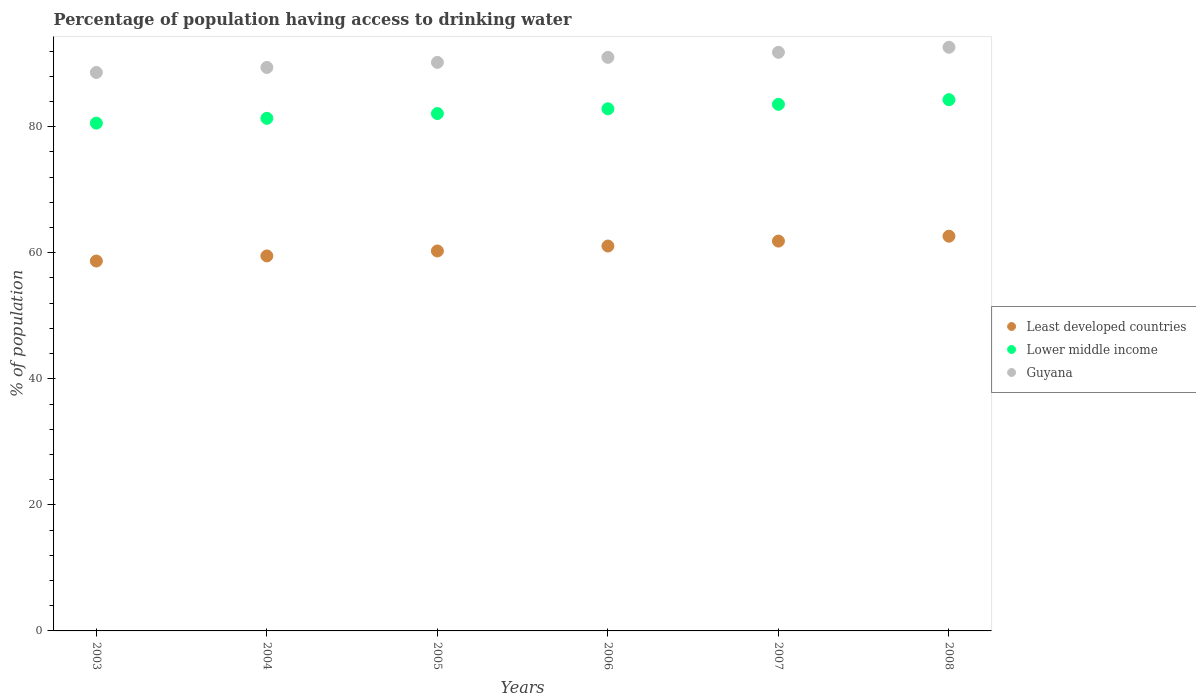What is the percentage of population having access to drinking water in Lower middle income in 2006?
Your response must be concise. 82.84. Across all years, what is the maximum percentage of population having access to drinking water in Guyana?
Provide a short and direct response. 92.6. Across all years, what is the minimum percentage of population having access to drinking water in Guyana?
Provide a succinct answer. 88.6. What is the total percentage of population having access to drinking water in Guyana in the graph?
Offer a very short reply. 543.6. What is the difference between the percentage of population having access to drinking water in Lower middle income in 2006 and that in 2008?
Make the answer very short. -1.45. What is the difference between the percentage of population having access to drinking water in Least developed countries in 2003 and the percentage of population having access to drinking water in Lower middle income in 2005?
Give a very brief answer. -23.4. What is the average percentage of population having access to drinking water in Lower middle income per year?
Your answer should be very brief. 82.44. In the year 2007, what is the difference between the percentage of population having access to drinking water in Least developed countries and percentage of population having access to drinking water in Guyana?
Your response must be concise. -29.95. In how many years, is the percentage of population having access to drinking water in Least developed countries greater than 20 %?
Your answer should be compact. 6. What is the ratio of the percentage of population having access to drinking water in Lower middle income in 2003 to that in 2008?
Make the answer very short. 0.96. Is the difference between the percentage of population having access to drinking water in Least developed countries in 2007 and 2008 greater than the difference between the percentage of population having access to drinking water in Guyana in 2007 and 2008?
Your response must be concise. Yes. What is the difference between the highest and the second highest percentage of population having access to drinking water in Guyana?
Make the answer very short. 0.8. What is the difference between the highest and the lowest percentage of population having access to drinking water in Lower middle income?
Offer a terse response. 3.72. Is it the case that in every year, the sum of the percentage of population having access to drinking water in Guyana and percentage of population having access to drinking water in Least developed countries  is greater than the percentage of population having access to drinking water in Lower middle income?
Give a very brief answer. Yes. Is the percentage of population having access to drinking water in Lower middle income strictly less than the percentage of population having access to drinking water in Guyana over the years?
Offer a very short reply. Yes. How many dotlines are there?
Give a very brief answer. 3. Where does the legend appear in the graph?
Offer a terse response. Center right. How many legend labels are there?
Make the answer very short. 3. How are the legend labels stacked?
Your answer should be very brief. Vertical. What is the title of the graph?
Ensure brevity in your answer.  Percentage of population having access to drinking water. What is the label or title of the Y-axis?
Keep it short and to the point. % of population. What is the % of population of Least developed countries in 2003?
Keep it short and to the point. 58.69. What is the % of population of Lower middle income in 2003?
Your answer should be compact. 80.56. What is the % of population of Guyana in 2003?
Offer a terse response. 88.6. What is the % of population of Least developed countries in 2004?
Give a very brief answer. 59.5. What is the % of population in Lower middle income in 2004?
Your answer should be very brief. 81.33. What is the % of population in Guyana in 2004?
Your answer should be compact. 89.4. What is the % of population in Least developed countries in 2005?
Make the answer very short. 60.28. What is the % of population in Lower middle income in 2005?
Offer a very short reply. 82.08. What is the % of population of Guyana in 2005?
Keep it short and to the point. 90.2. What is the % of population of Least developed countries in 2006?
Provide a succinct answer. 61.06. What is the % of population in Lower middle income in 2006?
Your response must be concise. 82.84. What is the % of population in Guyana in 2006?
Offer a terse response. 91. What is the % of population in Least developed countries in 2007?
Give a very brief answer. 61.85. What is the % of population of Lower middle income in 2007?
Your answer should be very brief. 83.55. What is the % of population in Guyana in 2007?
Offer a very short reply. 91.8. What is the % of population in Least developed countries in 2008?
Make the answer very short. 62.62. What is the % of population of Lower middle income in 2008?
Provide a short and direct response. 84.28. What is the % of population in Guyana in 2008?
Give a very brief answer. 92.6. Across all years, what is the maximum % of population of Least developed countries?
Provide a short and direct response. 62.62. Across all years, what is the maximum % of population in Lower middle income?
Provide a succinct answer. 84.28. Across all years, what is the maximum % of population in Guyana?
Offer a terse response. 92.6. Across all years, what is the minimum % of population in Least developed countries?
Your answer should be compact. 58.69. Across all years, what is the minimum % of population in Lower middle income?
Provide a short and direct response. 80.56. Across all years, what is the minimum % of population of Guyana?
Your answer should be very brief. 88.6. What is the total % of population of Least developed countries in the graph?
Offer a terse response. 364. What is the total % of population in Lower middle income in the graph?
Keep it short and to the point. 494.64. What is the total % of population in Guyana in the graph?
Make the answer very short. 543.6. What is the difference between the % of population of Least developed countries in 2003 and that in 2004?
Make the answer very short. -0.81. What is the difference between the % of population of Lower middle income in 2003 and that in 2004?
Provide a succinct answer. -0.76. What is the difference between the % of population of Guyana in 2003 and that in 2004?
Offer a terse response. -0.8. What is the difference between the % of population in Least developed countries in 2003 and that in 2005?
Keep it short and to the point. -1.59. What is the difference between the % of population in Lower middle income in 2003 and that in 2005?
Provide a succinct answer. -1.52. What is the difference between the % of population of Least developed countries in 2003 and that in 2006?
Keep it short and to the point. -2.38. What is the difference between the % of population in Lower middle income in 2003 and that in 2006?
Your answer should be very brief. -2.27. What is the difference between the % of population in Least developed countries in 2003 and that in 2007?
Offer a terse response. -3.16. What is the difference between the % of population in Lower middle income in 2003 and that in 2007?
Your answer should be very brief. -2.98. What is the difference between the % of population of Guyana in 2003 and that in 2007?
Your response must be concise. -3.2. What is the difference between the % of population of Least developed countries in 2003 and that in 2008?
Your answer should be compact. -3.94. What is the difference between the % of population of Lower middle income in 2003 and that in 2008?
Ensure brevity in your answer.  -3.72. What is the difference between the % of population of Least developed countries in 2004 and that in 2005?
Make the answer very short. -0.79. What is the difference between the % of population of Lower middle income in 2004 and that in 2005?
Give a very brief answer. -0.76. What is the difference between the % of population of Least developed countries in 2004 and that in 2006?
Ensure brevity in your answer.  -1.57. What is the difference between the % of population in Lower middle income in 2004 and that in 2006?
Offer a very short reply. -1.51. What is the difference between the % of population of Guyana in 2004 and that in 2006?
Make the answer very short. -1.6. What is the difference between the % of population of Least developed countries in 2004 and that in 2007?
Keep it short and to the point. -2.35. What is the difference between the % of population of Lower middle income in 2004 and that in 2007?
Your answer should be compact. -2.22. What is the difference between the % of population of Guyana in 2004 and that in 2007?
Offer a very short reply. -2.4. What is the difference between the % of population in Least developed countries in 2004 and that in 2008?
Keep it short and to the point. -3.13. What is the difference between the % of population in Lower middle income in 2004 and that in 2008?
Your answer should be compact. -2.96. What is the difference between the % of population in Guyana in 2004 and that in 2008?
Your answer should be very brief. -3.2. What is the difference between the % of population in Least developed countries in 2005 and that in 2006?
Offer a very short reply. -0.78. What is the difference between the % of population of Lower middle income in 2005 and that in 2006?
Provide a short and direct response. -0.75. What is the difference between the % of population of Least developed countries in 2005 and that in 2007?
Offer a very short reply. -1.57. What is the difference between the % of population in Lower middle income in 2005 and that in 2007?
Offer a very short reply. -1.46. What is the difference between the % of population in Least developed countries in 2005 and that in 2008?
Ensure brevity in your answer.  -2.34. What is the difference between the % of population of Lower middle income in 2005 and that in 2008?
Make the answer very short. -2.2. What is the difference between the % of population in Least developed countries in 2006 and that in 2007?
Make the answer very short. -0.78. What is the difference between the % of population of Lower middle income in 2006 and that in 2007?
Your response must be concise. -0.71. What is the difference between the % of population of Least developed countries in 2006 and that in 2008?
Keep it short and to the point. -1.56. What is the difference between the % of population of Lower middle income in 2006 and that in 2008?
Offer a very short reply. -1.45. What is the difference between the % of population in Guyana in 2006 and that in 2008?
Ensure brevity in your answer.  -1.6. What is the difference between the % of population in Least developed countries in 2007 and that in 2008?
Your answer should be compact. -0.77. What is the difference between the % of population in Lower middle income in 2007 and that in 2008?
Offer a terse response. -0.74. What is the difference between the % of population of Least developed countries in 2003 and the % of population of Lower middle income in 2004?
Your answer should be compact. -22.64. What is the difference between the % of population of Least developed countries in 2003 and the % of population of Guyana in 2004?
Give a very brief answer. -30.71. What is the difference between the % of population of Lower middle income in 2003 and the % of population of Guyana in 2004?
Ensure brevity in your answer.  -8.84. What is the difference between the % of population in Least developed countries in 2003 and the % of population in Lower middle income in 2005?
Your answer should be compact. -23.4. What is the difference between the % of population in Least developed countries in 2003 and the % of population in Guyana in 2005?
Offer a very short reply. -31.51. What is the difference between the % of population of Lower middle income in 2003 and the % of population of Guyana in 2005?
Your answer should be very brief. -9.64. What is the difference between the % of population of Least developed countries in 2003 and the % of population of Lower middle income in 2006?
Keep it short and to the point. -24.15. What is the difference between the % of population of Least developed countries in 2003 and the % of population of Guyana in 2006?
Your response must be concise. -32.31. What is the difference between the % of population in Lower middle income in 2003 and the % of population in Guyana in 2006?
Make the answer very short. -10.44. What is the difference between the % of population in Least developed countries in 2003 and the % of population in Lower middle income in 2007?
Ensure brevity in your answer.  -24.86. What is the difference between the % of population in Least developed countries in 2003 and the % of population in Guyana in 2007?
Ensure brevity in your answer.  -33.11. What is the difference between the % of population of Lower middle income in 2003 and the % of population of Guyana in 2007?
Provide a succinct answer. -11.24. What is the difference between the % of population in Least developed countries in 2003 and the % of population in Lower middle income in 2008?
Offer a terse response. -25.6. What is the difference between the % of population in Least developed countries in 2003 and the % of population in Guyana in 2008?
Provide a succinct answer. -33.91. What is the difference between the % of population of Lower middle income in 2003 and the % of population of Guyana in 2008?
Give a very brief answer. -12.04. What is the difference between the % of population of Least developed countries in 2004 and the % of population of Lower middle income in 2005?
Give a very brief answer. -22.59. What is the difference between the % of population of Least developed countries in 2004 and the % of population of Guyana in 2005?
Your answer should be very brief. -30.7. What is the difference between the % of population of Lower middle income in 2004 and the % of population of Guyana in 2005?
Provide a short and direct response. -8.87. What is the difference between the % of population in Least developed countries in 2004 and the % of population in Lower middle income in 2006?
Your response must be concise. -23.34. What is the difference between the % of population in Least developed countries in 2004 and the % of population in Guyana in 2006?
Offer a very short reply. -31.5. What is the difference between the % of population of Lower middle income in 2004 and the % of population of Guyana in 2006?
Your answer should be very brief. -9.67. What is the difference between the % of population in Least developed countries in 2004 and the % of population in Lower middle income in 2007?
Offer a very short reply. -24.05. What is the difference between the % of population of Least developed countries in 2004 and the % of population of Guyana in 2007?
Offer a terse response. -32.3. What is the difference between the % of population of Lower middle income in 2004 and the % of population of Guyana in 2007?
Keep it short and to the point. -10.47. What is the difference between the % of population of Least developed countries in 2004 and the % of population of Lower middle income in 2008?
Make the answer very short. -24.79. What is the difference between the % of population in Least developed countries in 2004 and the % of population in Guyana in 2008?
Your response must be concise. -33.1. What is the difference between the % of population in Lower middle income in 2004 and the % of population in Guyana in 2008?
Your answer should be very brief. -11.27. What is the difference between the % of population in Least developed countries in 2005 and the % of population in Lower middle income in 2006?
Your answer should be compact. -22.56. What is the difference between the % of population in Least developed countries in 2005 and the % of population in Guyana in 2006?
Provide a short and direct response. -30.72. What is the difference between the % of population of Lower middle income in 2005 and the % of population of Guyana in 2006?
Keep it short and to the point. -8.92. What is the difference between the % of population in Least developed countries in 2005 and the % of population in Lower middle income in 2007?
Provide a succinct answer. -23.27. What is the difference between the % of population in Least developed countries in 2005 and the % of population in Guyana in 2007?
Your response must be concise. -31.52. What is the difference between the % of population of Lower middle income in 2005 and the % of population of Guyana in 2007?
Your answer should be compact. -9.72. What is the difference between the % of population in Least developed countries in 2005 and the % of population in Lower middle income in 2008?
Make the answer very short. -24. What is the difference between the % of population of Least developed countries in 2005 and the % of population of Guyana in 2008?
Provide a succinct answer. -32.32. What is the difference between the % of population of Lower middle income in 2005 and the % of population of Guyana in 2008?
Your answer should be compact. -10.52. What is the difference between the % of population in Least developed countries in 2006 and the % of population in Lower middle income in 2007?
Provide a succinct answer. -22.48. What is the difference between the % of population in Least developed countries in 2006 and the % of population in Guyana in 2007?
Your response must be concise. -30.74. What is the difference between the % of population of Lower middle income in 2006 and the % of population of Guyana in 2007?
Your answer should be very brief. -8.96. What is the difference between the % of population of Least developed countries in 2006 and the % of population of Lower middle income in 2008?
Give a very brief answer. -23.22. What is the difference between the % of population in Least developed countries in 2006 and the % of population in Guyana in 2008?
Provide a short and direct response. -31.54. What is the difference between the % of population in Lower middle income in 2006 and the % of population in Guyana in 2008?
Ensure brevity in your answer.  -9.76. What is the difference between the % of population of Least developed countries in 2007 and the % of population of Lower middle income in 2008?
Ensure brevity in your answer.  -22.44. What is the difference between the % of population of Least developed countries in 2007 and the % of population of Guyana in 2008?
Offer a very short reply. -30.75. What is the difference between the % of population in Lower middle income in 2007 and the % of population in Guyana in 2008?
Your response must be concise. -9.05. What is the average % of population in Least developed countries per year?
Your answer should be very brief. 60.67. What is the average % of population of Lower middle income per year?
Give a very brief answer. 82.44. What is the average % of population of Guyana per year?
Provide a succinct answer. 90.6. In the year 2003, what is the difference between the % of population in Least developed countries and % of population in Lower middle income?
Give a very brief answer. -21.88. In the year 2003, what is the difference between the % of population in Least developed countries and % of population in Guyana?
Provide a succinct answer. -29.91. In the year 2003, what is the difference between the % of population in Lower middle income and % of population in Guyana?
Your response must be concise. -8.04. In the year 2004, what is the difference between the % of population in Least developed countries and % of population in Lower middle income?
Your response must be concise. -21.83. In the year 2004, what is the difference between the % of population in Least developed countries and % of population in Guyana?
Make the answer very short. -29.9. In the year 2004, what is the difference between the % of population of Lower middle income and % of population of Guyana?
Keep it short and to the point. -8.07. In the year 2005, what is the difference between the % of population of Least developed countries and % of population of Lower middle income?
Keep it short and to the point. -21.8. In the year 2005, what is the difference between the % of population in Least developed countries and % of population in Guyana?
Your response must be concise. -29.92. In the year 2005, what is the difference between the % of population of Lower middle income and % of population of Guyana?
Your response must be concise. -8.12. In the year 2006, what is the difference between the % of population in Least developed countries and % of population in Lower middle income?
Ensure brevity in your answer.  -21.77. In the year 2006, what is the difference between the % of population of Least developed countries and % of population of Guyana?
Give a very brief answer. -29.94. In the year 2006, what is the difference between the % of population in Lower middle income and % of population in Guyana?
Give a very brief answer. -8.16. In the year 2007, what is the difference between the % of population of Least developed countries and % of population of Lower middle income?
Provide a succinct answer. -21.7. In the year 2007, what is the difference between the % of population of Least developed countries and % of population of Guyana?
Your answer should be compact. -29.95. In the year 2007, what is the difference between the % of population of Lower middle income and % of population of Guyana?
Give a very brief answer. -8.25. In the year 2008, what is the difference between the % of population in Least developed countries and % of population in Lower middle income?
Your answer should be very brief. -21.66. In the year 2008, what is the difference between the % of population of Least developed countries and % of population of Guyana?
Provide a succinct answer. -29.98. In the year 2008, what is the difference between the % of population in Lower middle income and % of population in Guyana?
Offer a very short reply. -8.32. What is the ratio of the % of population of Least developed countries in 2003 to that in 2004?
Offer a terse response. 0.99. What is the ratio of the % of population of Lower middle income in 2003 to that in 2004?
Give a very brief answer. 0.99. What is the ratio of the % of population of Least developed countries in 2003 to that in 2005?
Provide a short and direct response. 0.97. What is the ratio of the % of population of Lower middle income in 2003 to that in 2005?
Provide a succinct answer. 0.98. What is the ratio of the % of population of Guyana in 2003 to that in 2005?
Give a very brief answer. 0.98. What is the ratio of the % of population of Least developed countries in 2003 to that in 2006?
Give a very brief answer. 0.96. What is the ratio of the % of population in Lower middle income in 2003 to that in 2006?
Keep it short and to the point. 0.97. What is the ratio of the % of population of Guyana in 2003 to that in 2006?
Make the answer very short. 0.97. What is the ratio of the % of population in Least developed countries in 2003 to that in 2007?
Offer a very short reply. 0.95. What is the ratio of the % of population in Lower middle income in 2003 to that in 2007?
Provide a short and direct response. 0.96. What is the ratio of the % of population in Guyana in 2003 to that in 2007?
Provide a succinct answer. 0.97. What is the ratio of the % of population of Least developed countries in 2003 to that in 2008?
Provide a succinct answer. 0.94. What is the ratio of the % of population of Lower middle income in 2003 to that in 2008?
Offer a very short reply. 0.96. What is the ratio of the % of population in Guyana in 2003 to that in 2008?
Offer a terse response. 0.96. What is the ratio of the % of population in Least developed countries in 2004 to that in 2005?
Offer a terse response. 0.99. What is the ratio of the % of population in Guyana in 2004 to that in 2005?
Provide a succinct answer. 0.99. What is the ratio of the % of population of Least developed countries in 2004 to that in 2006?
Provide a succinct answer. 0.97. What is the ratio of the % of population of Lower middle income in 2004 to that in 2006?
Your response must be concise. 0.98. What is the ratio of the % of population of Guyana in 2004 to that in 2006?
Provide a succinct answer. 0.98. What is the ratio of the % of population of Least developed countries in 2004 to that in 2007?
Offer a terse response. 0.96. What is the ratio of the % of population in Lower middle income in 2004 to that in 2007?
Give a very brief answer. 0.97. What is the ratio of the % of population in Guyana in 2004 to that in 2007?
Your answer should be very brief. 0.97. What is the ratio of the % of population in Lower middle income in 2004 to that in 2008?
Provide a short and direct response. 0.96. What is the ratio of the % of population of Guyana in 2004 to that in 2008?
Your answer should be very brief. 0.97. What is the ratio of the % of population in Least developed countries in 2005 to that in 2006?
Ensure brevity in your answer.  0.99. What is the ratio of the % of population of Lower middle income in 2005 to that in 2006?
Make the answer very short. 0.99. What is the ratio of the % of population in Least developed countries in 2005 to that in 2007?
Your answer should be compact. 0.97. What is the ratio of the % of population in Lower middle income in 2005 to that in 2007?
Give a very brief answer. 0.98. What is the ratio of the % of population in Guyana in 2005 to that in 2007?
Give a very brief answer. 0.98. What is the ratio of the % of population in Least developed countries in 2005 to that in 2008?
Offer a very short reply. 0.96. What is the ratio of the % of population of Lower middle income in 2005 to that in 2008?
Make the answer very short. 0.97. What is the ratio of the % of population of Guyana in 2005 to that in 2008?
Your answer should be compact. 0.97. What is the ratio of the % of population of Least developed countries in 2006 to that in 2007?
Keep it short and to the point. 0.99. What is the ratio of the % of population of Lower middle income in 2006 to that in 2007?
Provide a succinct answer. 0.99. What is the ratio of the % of population of Guyana in 2006 to that in 2007?
Your answer should be compact. 0.99. What is the ratio of the % of population in Least developed countries in 2006 to that in 2008?
Offer a terse response. 0.98. What is the ratio of the % of population in Lower middle income in 2006 to that in 2008?
Provide a short and direct response. 0.98. What is the ratio of the % of population in Guyana in 2006 to that in 2008?
Offer a terse response. 0.98. What is the ratio of the % of population of Least developed countries in 2007 to that in 2008?
Offer a terse response. 0.99. What is the ratio of the % of population in Lower middle income in 2007 to that in 2008?
Ensure brevity in your answer.  0.99. What is the ratio of the % of population in Guyana in 2007 to that in 2008?
Your response must be concise. 0.99. What is the difference between the highest and the second highest % of population in Least developed countries?
Ensure brevity in your answer.  0.77. What is the difference between the highest and the second highest % of population of Lower middle income?
Provide a succinct answer. 0.74. What is the difference between the highest and the second highest % of population in Guyana?
Make the answer very short. 0.8. What is the difference between the highest and the lowest % of population in Least developed countries?
Ensure brevity in your answer.  3.94. What is the difference between the highest and the lowest % of population in Lower middle income?
Make the answer very short. 3.72. 